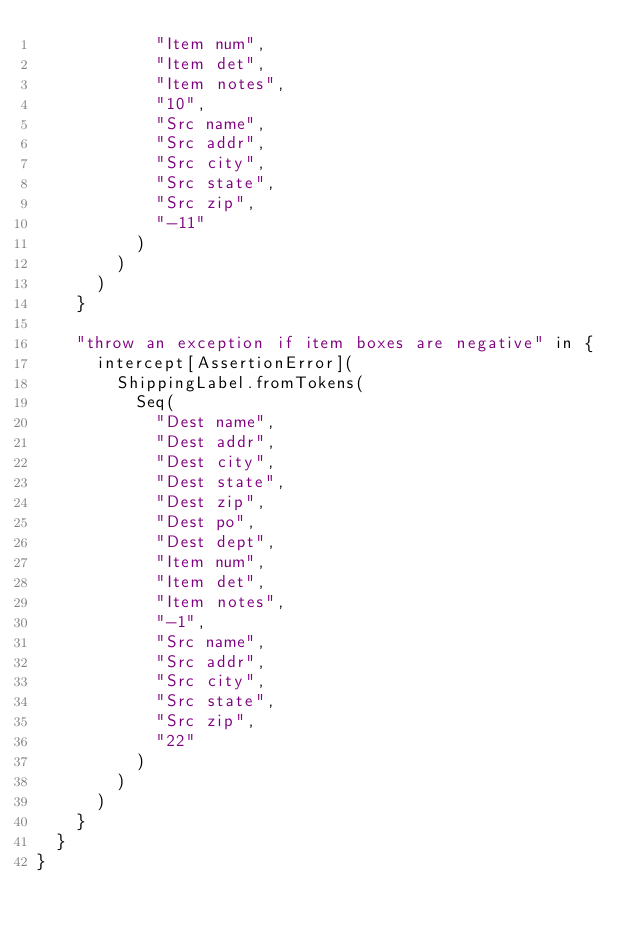<code> <loc_0><loc_0><loc_500><loc_500><_Scala_>            "Item num",
            "Item det",
            "Item notes",
            "10",
            "Src name",
            "Src addr",
            "Src city",
            "Src state",
            "Src zip",
            "-11"
          )
        )
      )
    }

    "throw an exception if item boxes are negative" in {
      intercept[AssertionError](
        ShippingLabel.fromTokens(
          Seq(
            "Dest name",
            "Dest addr",
            "Dest city",
            "Dest state",
            "Dest zip",
            "Dest po",
            "Dest dept",
            "Item num",
            "Item det",
            "Item notes",
            "-1",
            "Src name",
            "Src addr",
            "Src city",
            "Src state",
            "Src zip",
            "22"
          )
        )
      )
    }
  }
}
</code> 